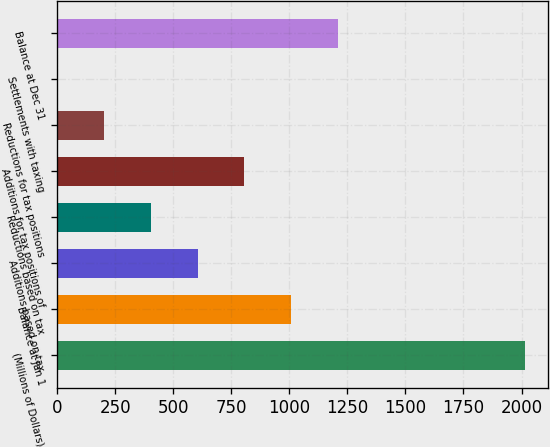<chart> <loc_0><loc_0><loc_500><loc_500><bar_chart><fcel>(Millions of Dollars)<fcel>Balance at Jan 1<fcel>Additions based on tax<fcel>Reductions based on tax<fcel>Additions for tax positions of<fcel>Reductions for tax positions<fcel>Settlements with taxing<fcel>Balance at Dec 31<nl><fcel>2015<fcel>1007.65<fcel>604.71<fcel>403.24<fcel>806.18<fcel>201.77<fcel>0.3<fcel>1209.12<nl></chart> 